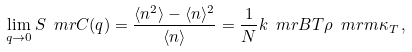Convert formula to latex. <formula><loc_0><loc_0><loc_500><loc_500>\lim _ { q \rightarrow 0 } S _ { \ } m r { C } ( q ) = \frac { \langle n ^ { 2 } \rangle - \langle n \rangle ^ { 2 } } { \langle n \rangle } = \frac { 1 } { N } k _ { \ } m r { B } T \rho _ { \ } m r { m } \kappa _ { T } \, ,</formula> 